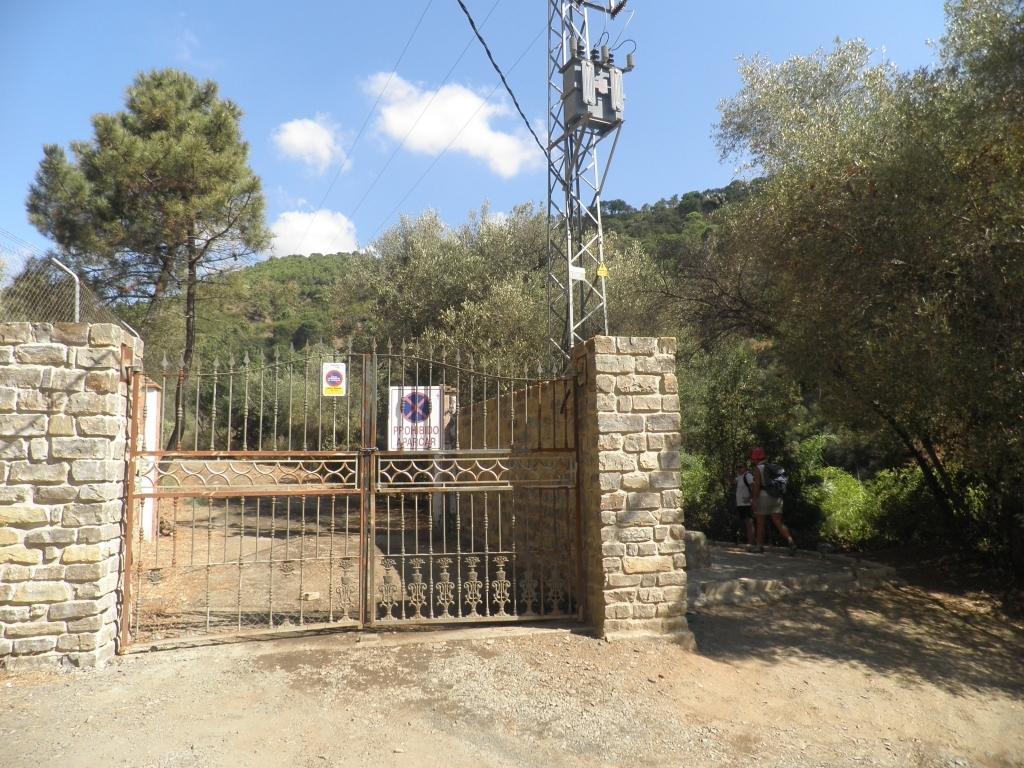Can you describe this image briefly? In this image we can see there are people walking on the ground. And there is a gate attached to the wall. And there are trees, boards, antenna and the sky. 